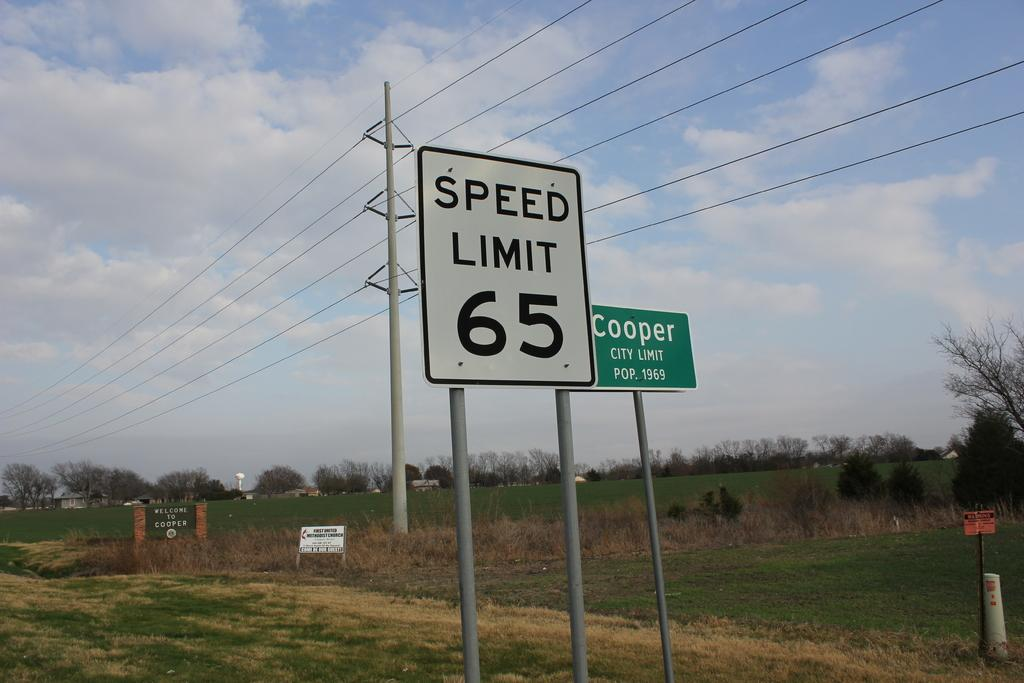<image>
Describe the image concisely. a speed limit sign that has 65 on it 